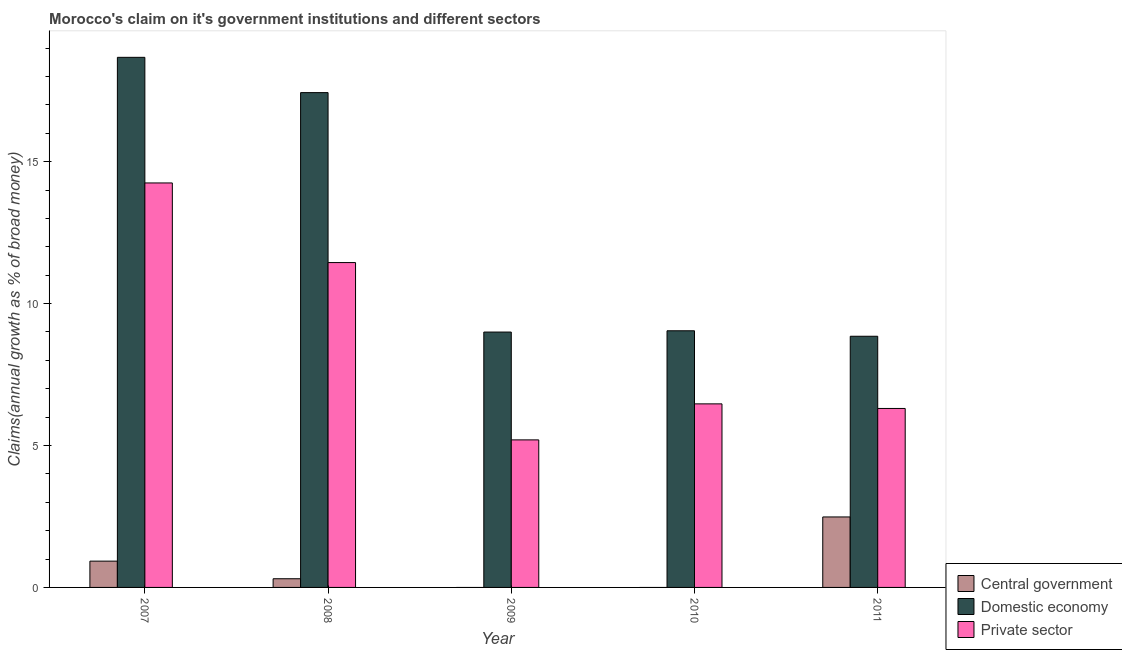How many different coloured bars are there?
Give a very brief answer. 3. How many groups of bars are there?
Your answer should be compact. 5. Are the number of bars on each tick of the X-axis equal?
Keep it short and to the point. No. How many bars are there on the 5th tick from the left?
Offer a very short reply. 3. How many bars are there on the 5th tick from the right?
Ensure brevity in your answer.  3. What is the label of the 5th group of bars from the left?
Make the answer very short. 2011. In how many cases, is the number of bars for a given year not equal to the number of legend labels?
Offer a very short reply. 2. What is the percentage of claim on the domestic economy in 2008?
Ensure brevity in your answer.  17.43. Across all years, what is the maximum percentage of claim on the central government?
Make the answer very short. 2.48. Across all years, what is the minimum percentage of claim on the private sector?
Provide a short and direct response. 5.2. In which year was the percentage of claim on the central government maximum?
Offer a terse response. 2011. What is the total percentage of claim on the private sector in the graph?
Keep it short and to the point. 43.67. What is the difference between the percentage of claim on the domestic economy in 2009 and that in 2011?
Offer a terse response. 0.15. What is the difference between the percentage of claim on the domestic economy in 2010 and the percentage of claim on the private sector in 2009?
Offer a terse response. 0.04. What is the average percentage of claim on the domestic economy per year?
Ensure brevity in your answer.  12.6. In how many years, is the percentage of claim on the central government greater than 17 %?
Offer a very short reply. 0. What is the ratio of the percentage of claim on the domestic economy in 2007 to that in 2008?
Your answer should be compact. 1.07. Is the percentage of claim on the domestic economy in 2008 less than that in 2009?
Offer a very short reply. No. What is the difference between the highest and the second highest percentage of claim on the central government?
Provide a short and direct response. 1.56. What is the difference between the highest and the lowest percentage of claim on the central government?
Keep it short and to the point. 2.48. Is it the case that in every year, the sum of the percentage of claim on the central government and percentage of claim on the domestic economy is greater than the percentage of claim on the private sector?
Your response must be concise. Yes. How many bars are there?
Ensure brevity in your answer.  13. How many years are there in the graph?
Offer a very short reply. 5. What is the difference between two consecutive major ticks on the Y-axis?
Provide a succinct answer. 5. Are the values on the major ticks of Y-axis written in scientific E-notation?
Provide a succinct answer. No. Does the graph contain any zero values?
Your response must be concise. Yes. How many legend labels are there?
Ensure brevity in your answer.  3. What is the title of the graph?
Your answer should be very brief. Morocco's claim on it's government institutions and different sectors. Does "Coal sources" appear as one of the legend labels in the graph?
Your answer should be compact. No. What is the label or title of the Y-axis?
Your response must be concise. Claims(annual growth as % of broad money). What is the Claims(annual growth as % of broad money) of Central government in 2007?
Your answer should be compact. 0.93. What is the Claims(annual growth as % of broad money) in Domestic economy in 2007?
Provide a succinct answer. 18.68. What is the Claims(annual growth as % of broad money) of Private sector in 2007?
Offer a terse response. 14.25. What is the Claims(annual growth as % of broad money) of Central government in 2008?
Offer a very short reply. 0.31. What is the Claims(annual growth as % of broad money) in Domestic economy in 2008?
Offer a terse response. 17.43. What is the Claims(annual growth as % of broad money) of Private sector in 2008?
Provide a succinct answer. 11.45. What is the Claims(annual growth as % of broad money) in Domestic economy in 2009?
Give a very brief answer. 9. What is the Claims(annual growth as % of broad money) of Private sector in 2009?
Provide a succinct answer. 5.2. What is the Claims(annual growth as % of broad money) of Central government in 2010?
Your response must be concise. 0. What is the Claims(annual growth as % of broad money) in Domestic economy in 2010?
Your answer should be compact. 9.04. What is the Claims(annual growth as % of broad money) in Private sector in 2010?
Ensure brevity in your answer.  6.47. What is the Claims(annual growth as % of broad money) of Central government in 2011?
Keep it short and to the point. 2.48. What is the Claims(annual growth as % of broad money) in Domestic economy in 2011?
Make the answer very short. 8.85. What is the Claims(annual growth as % of broad money) of Private sector in 2011?
Ensure brevity in your answer.  6.31. Across all years, what is the maximum Claims(annual growth as % of broad money) in Central government?
Provide a succinct answer. 2.48. Across all years, what is the maximum Claims(annual growth as % of broad money) in Domestic economy?
Offer a very short reply. 18.68. Across all years, what is the maximum Claims(annual growth as % of broad money) in Private sector?
Your response must be concise. 14.25. Across all years, what is the minimum Claims(annual growth as % of broad money) of Central government?
Ensure brevity in your answer.  0. Across all years, what is the minimum Claims(annual growth as % of broad money) in Domestic economy?
Provide a short and direct response. 8.85. Across all years, what is the minimum Claims(annual growth as % of broad money) of Private sector?
Your answer should be very brief. 5.2. What is the total Claims(annual growth as % of broad money) of Central government in the graph?
Provide a short and direct response. 3.72. What is the total Claims(annual growth as % of broad money) in Domestic economy in the graph?
Provide a short and direct response. 63. What is the total Claims(annual growth as % of broad money) in Private sector in the graph?
Your answer should be very brief. 43.67. What is the difference between the Claims(annual growth as % of broad money) in Central government in 2007 and that in 2008?
Make the answer very short. 0.62. What is the difference between the Claims(annual growth as % of broad money) of Domestic economy in 2007 and that in 2008?
Your answer should be compact. 1.24. What is the difference between the Claims(annual growth as % of broad money) in Private sector in 2007 and that in 2008?
Provide a short and direct response. 2.81. What is the difference between the Claims(annual growth as % of broad money) in Domestic economy in 2007 and that in 2009?
Your answer should be very brief. 9.68. What is the difference between the Claims(annual growth as % of broad money) of Private sector in 2007 and that in 2009?
Provide a short and direct response. 9.05. What is the difference between the Claims(annual growth as % of broad money) in Domestic economy in 2007 and that in 2010?
Your answer should be very brief. 9.63. What is the difference between the Claims(annual growth as % of broad money) in Private sector in 2007 and that in 2010?
Your answer should be compact. 7.78. What is the difference between the Claims(annual growth as % of broad money) in Central government in 2007 and that in 2011?
Ensure brevity in your answer.  -1.56. What is the difference between the Claims(annual growth as % of broad money) in Domestic economy in 2007 and that in 2011?
Make the answer very short. 9.83. What is the difference between the Claims(annual growth as % of broad money) of Private sector in 2007 and that in 2011?
Ensure brevity in your answer.  7.95. What is the difference between the Claims(annual growth as % of broad money) in Domestic economy in 2008 and that in 2009?
Offer a terse response. 8.44. What is the difference between the Claims(annual growth as % of broad money) in Private sector in 2008 and that in 2009?
Give a very brief answer. 6.25. What is the difference between the Claims(annual growth as % of broad money) of Domestic economy in 2008 and that in 2010?
Keep it short and to the point. 8.39. What is the difference between the Claims(annual growth as % of broad money) in Private sector in 2008 and that in 2010?
Offer a very short reply. 4.98. What is the difference between the Claims(annual growth as % of broad money) of Central government in 2008 and that in 2011?
Ensure brevity in your answer.  -2.18. What is the difference between the Claims(annual growth as % of broad money) of Domestic economy in 2008 and that in 2011?
Your answer should be very brief. 8.58. What is the difference between the Claims(annual growth as % of broad money) of Private sector in 2008 and that in 2011?
Your response must be concise. 5.14. What is the difference between the Claims(annual growth as % of broad money) in Domestic economy in 2009 and that in 2010?
Your answer should be compact. -0.04. What is the difference between the Claims(annual growth as % of broad money) in Private sector in 2009 and that in 2010?
Your answer should be compact. -1.27. What is the difference between the Claims(annual growth as % of broad money) in Domestic economy in 2009 and that in 2011?
Your response must be concise. 0.15. What is the difference between the Claims(annual growth as % of broad money) in Private sector in 2009 and that in 2011?
Offer a terse response. -1.11. What is the difference between the Claims(annual growth as % of broad money) in Domestic economy in 2010 and that in 2011?
Make the answer very short. 0.19. What is the difference between the Claims(annual growth as % of broad money) of Private sector in 2010 and that in 2011?
Make the answer very short. 0.16. What is the difference between the Claims(annual growth as % of broad money) in Central government in 2007 and the Claims(annual growth as % of broad money) in Domestic economy in 2008?
Your answer should be compact. -16.51. What is the difference between the Claims(annual growth as % of broad money) of Central government in 2007 and the Claims(annual growth as % of broad money) of Private sector in 2008?
Your response must be concise. -10.52. What is the difference between the Claims(annual growth as % of broad money) in Domestic economy in 2007 and the Claims(annual growth as % of broad money) in Private sector in 2008?
Your answer should be very brief. 7.23. What is the difference between the Claims(annual growth as % of broad money) in Central government in 2007 and the Claims(annual growth as % of broad money) in Domestic economy in 2009?
Ensure brevity in your answer.  -8.07. What is the difference between the Claims(annual growth as % of broad money) in Central government in 2007 and the Claims(annual growth as % of broad money) in Private sector in 2009?
Your answer should be compact. -4.27. What is the difference between the Claims(annual growth as % of broad money) of Domestic economy in 2007 and the Claims(annual growth as % of broad money) of Private sector in 2009?
Provide a short and direct response. 13.48. What is the difference between the Claims(annual growth as % of broad money) in Central government in 2007 and the Claims(annual growth as % of broad money) in Domestic economy in 2010?
Your answer should be very brief. -8.12. What is the difference between the Claims(annual growth as % of broad money) in Central government in 2007 and the Claims(annual growth as % of broad money) in Private sector in 2010?
Offer a terse response. -5.54. What is the difference between the Claims(annual growth as % of broad money) in Domestic economy in 2007 and the Claims(annual growth as % of broad money) in Private sector in 2010?
Provide a succinct answer. 12.21. What is the difference between the Claims(annual growth as % of broad money) in Central government in 2007 and the Claims(annual growth as % of broad money) in Domestic economy in 2011?
Give a very brief answer. -7.92. What is the difference between the Claims(annual growth as % of broad money) of Central government in 2007 and the Claims(annual growth as % of broad money) of Private sector in 2011?
Offer a very short reply. -5.38. What is the difference between the Claims(annual growth as % of broad money) of Domestic economy in 2007 and the Claims(annual growth as % of broad money) of Private sector in 2011?
Make the answer very short. 12.37. What is the difference between the Claims(annual growth as % of broad money) of Central government in 2008 and the Claims(annual growth as % of broad money) of Domestic economy in 2009?
Give a very brief answer. -8.69. What is the difference between the Claims(annual growth as % of broad money) of Central government in 2008 and the Claims(annual growth as % of broad money) of Private sector in 2009?
Give a very brief answer. -4.89. What is the difference between the Claims(annual growth as % of broad money) in Domestic economy in 2008 and the Claims(annual growth as % of broad money) in Private sector in 2009?
Give a very brief answer. 12.24. What is the difference between the Claims(annual growth as % of broad money) in Central government in 2008 and the Claims(annual growth as % of broad money) in Domestic economy in 2010?
Offer a terse response. -8.74. What is the difference between the Claims(annual growth as % of broad money) in Central government in 2008 and the Claims(annual growth as % of broad money) in Private sector in 2010?
Offer a very short reply. -6.16. What is the difference between the Claims(annual growth as % of broad money) in Domestic economy in 2008 and the Claims(annual growth as % of broad money) in Private sector in 2010?
Provide a succinct answer. 10.97. What is the difference between the Claims(annual growth as % of broad money) in Central government in 2008 and the Claims(annual growth as % of broad money) in Domestic economy in 2011?
Offer a terse response. -8.54. What is the difference between the Claims(annual growth as % of broad money) in Central government in 2008 and the Claims(annual growth as % of broad money) in Private sector in 2011?
Your response must be concise. -6. What is the difference between the Claims(annual growth as % of broad money) in Domestic economy in 2008 and the Claims(annual growth as % of broad money) in Private sector in 2011?
Provide a succinct answer. 11.13. What is the difference between the Claims(annual growth as % of broad money) of Domestic economy in 2009 and the Claims(annual growth as % of broad money) of Private sector in 2010?
Ensure brevity in your answer.  2.53. What is the difference between the Claims(annual growth as % of broad money) of Domestic economy in 2009 and the Claims(annual growth as % of broad money) of Private sector in 2011?
Provide a succinct answer. 2.69. What is the difference between the Claims(annual growth as % of broad money) of Domestic economy in 2010 and the Claims(annual growth as % of broad money) of Private sector in 2011?
Ensure brevity in your answer.  2.74. What is the average Claims(annual growth as % of broad money) in Central government per year?
Provide a succinct answer. 0.74. What is the average Claims(annual growth as % of broad money) in Domestic economy per year?
Offer a very short reply. 12.6. What is the average Claims(annual growth as % of broad money) in Private sector per year?
Make the answer very short. 8.73. In the year 2007, what is the difference between the Claims(annual growth as % of broad money) of Central government and Claims(annual growth as % of broad money) of Domestic economy?
Ensure brevity in your answer.  -17.75. In the year 2007, what is the difference between the Claims(annual growth as % of broad money) in Central government and Claims(annual growth as % of broad money) in Private sector?
Provide a short and direct response. -13.32. In the year 2007, what is the difference between the Claims(annual growth as % of broad money) of Domestic economy and Claims(annual growth as % of broad money) of Private sector?
Offer a very short reply. 4.43. In the year 2008, what is the difference between the Claims(annual growth as % of broad money) in Central government and Claims(annual growth as % of broad money) in Domestic economy?
Provide a short and direct response. -17.13. In the year 2008, what is the difference between the Claims(annual growth as % of broad money) in Central government and Claims(annual growth as % of broad money) in Private sector?
Ensure brevity in your answer.  -11.14. In the year 2008, what is the difference between the Claims(annual growth as % of broad money) in Domestic economy and Claims(annual growth as % of broad money) in Private sector?
Make the answer very short. 5.99. In the year 2009, what is the difference between the Claims(annual growth as % of broad money) in Domestic economy and Claims(annual growth as % of broad money) in Private sector?
Provide a succinct answer. 3.8. In the year 2010, what is the difference between the Claims(annual growth as % of broad money) of Domestic economy and Claims(annual growth as % of broad money) of Private sector?
Provide a short and direct response. 2.58. In the year 2011, what is the difference between the Claims(annual growth as % of broad money) of Central government and Claims(annual growth as % of broad money) of Domestic economy?
Your response must be concise. -6.37. In the year 2011, what is the difference between the Claims(annual growth as % of broad money) in Central government and Claims(annual growth as % of broad money) in Private sector?
Offer a terse response. -3.82. In the year 2011, what is the difference between the Claims(annual growth as % of broad money) in Domestic economy and Claims(annual growth as % of broad money) in Private sector?
Provide a succinct answer. 2.54. What is the ratio of the Claims(annual growth as % of broad money) in Central government in 2007 to that in 2008?
Offer a terse response. 3.03. What is the ratio of the Claims(annual growth as % of broad money) of Domestic economy in 2007 to that in 2008?
Ensure brevity in your answer.  1.07. What is the ratio of the Claims(annual growth as % of broad money) of Private sector in 2007 to that in 2008?
Give a very brief answer. 1.25. What is the ratio of the Claims(annual growth as % of broad money) in Domestic economy in 2007 to that in 2009?
Your answer should be compact. 2.08. What is the ratio of the Claims(annual growth as % of broad money) of Private sector in 2007 to that in 2009?
Your answer should be very brief. 2.74. What is the ratio of the Claims(annual growth as % of broad money) of Domestic economy in 2007 to that in 2010?
Make the answer very short. 2.07. What is the ratio of the Claims(annual growth as % of broad money) of Private sector in 2007 to that in 2010?
Provide a short and direct response. 2.2. What is the ratio of the Claims(annual growth as % of broad money) of Central government in 2007 to that in 2011?
Offer a terse response. 0.37. What is the ratio of the Claims(annual growth as % of broad money) in Domestic economy in 2007 to that in 2011?
Your response must be concise. 2.11. What is the ratio of the Claims(annual growth as % of broad money) in Private sector in 2007 to that in 2011?
Your answer should be very brief. 2.26. What is the ratio of the Claims(annual growth as % of broad money) of Domestic economy in 2008 to that in 2009?
Make the answer very short. 1.94. What is the ratio of the Claims(annual growth as % of broad money) of Private sector in 2008 to that in 2009?
Your answer should be very brief. 2.2. What is the ratio of the Claims(annual growth as % of broad money) of Domestic economy in 2008 to that in 2010?
Provide a short and direct response. 1.93. What is the ratio of the Claims(annual growth as % of broad money) in Private sector in 2008 to that in 2010?
Give a very brief answer. 1.77. What is the ratio of the Claims(annual growth as % of broad money) of Central government in 2008 to that in 2011?
Your response must be concise. 0.12. What is the ratio of the Claims(annual growth as % of broad money) in Domestic economy in 2008 to that in 2011?
Offer a terse response. 1.97. What is the ratio of the Claims(annual growth as % of broad money) in Private sector in 2008 to that in 2011?
Make the answer very short. 1.82. What is the ratio of the Claims(annual growth as % of broad money) of Domestic economy in 2009 to that in 2010?
Your answer should be very brief. 0.99. What is the ratio of the Claims(annual growth as % of broad money) in Private sector in 2009 to that in 2010?
Your answer should be very brief. 0.8. What is the ratio of the Claims(annual growth as % of broad money) in Domestic economy in 2009 to that in 2011?
Your answer should be very brief. 1.02. What is the ratio of the Claims(annual growth as % of broad money) of Private sector in 2009 to that in 2011?
Ensure brevity in your answer.  0.82. What is the ratio of the Claims(annual growth as % of broad money) in Domestic economy in 2010 to that in 2011?
Keep it short and to the point. 1.02. What is the ratio of the Claims(annual growth as % of broad money) of Private sector in 2010 to that in 2011?
Provide a short and direct response. 1.03. What is the difference between the highest and the second highest Claims(annual growth as % of broad money) of Central government?
Offer a very short reply. 1.56. What is the difference between the highest and the second highest Claims(annual growth as % of broad money) of Domestic economy?
Offer a very short reply. 1.24. What is the difference between the highest and the second highest Claims(annual growth as % of broad money) in Private sector?
Provide a short and direct response. 2.81. What is the difference between the highest and the lowest Claims(annual growth as % of broad money) of Central government?
Your answer should be very brief. 2.48. What is the difference between the highest and the lowest Claims(annual growth as % of broad money) in Domestic economy?
Provide a short and direct response. 9.83. What is the difference between the highest and the lowest Claims(annual growth as % of broad money) of Private sector?
Your response must be concise. 9.05. 